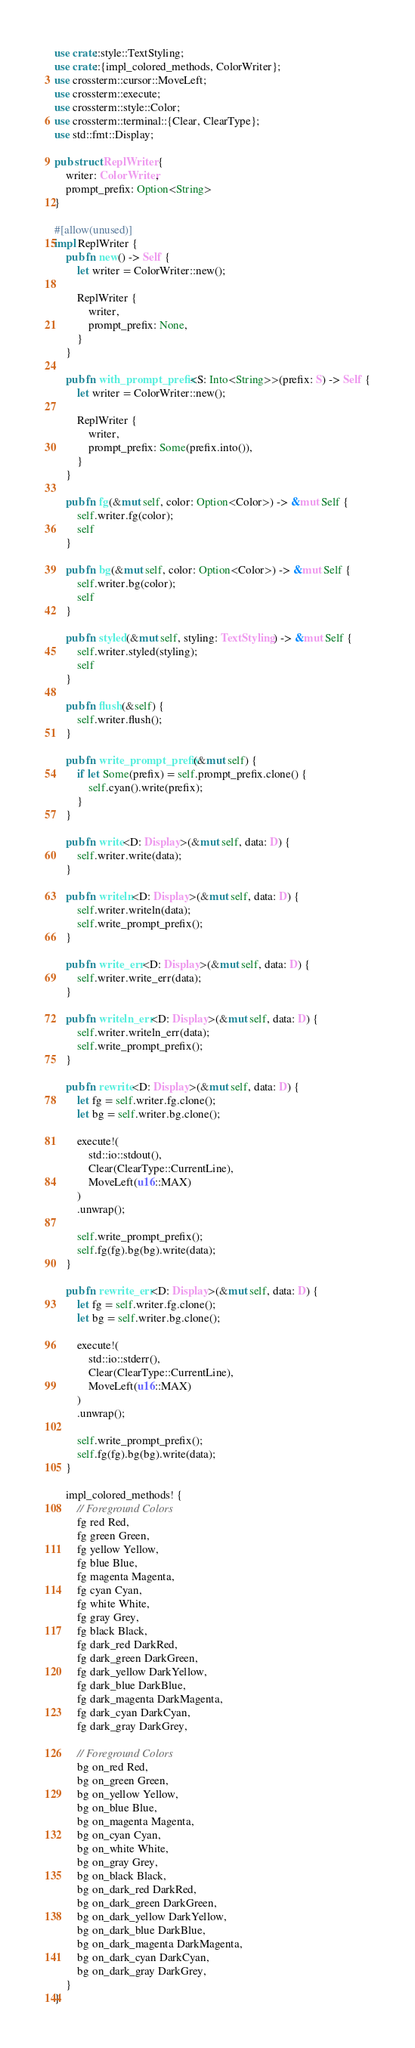Convert code to text. <code><loc_0><loc_0><loc_500><loc_500><_Rust_>use crate::style::TextStyling;
use crate::{impl_colored_methods, ColorWriter};
use crossterm::cursor::MoveLeft;
use crossterm::execute;
use crossterm::style::Color;
use crossterm::terminal::{Clear, ClearType};
use std::fmt::Display;

pub struct ReplWriter {
    writer: ColorWriter,
    prompt_prefix: Option<String>
}

#[allow(unused)]
impl ReplWriter {
    pub fn new() -> Self {
        let writer = ColorWriter::new();

        ReplWriter {
            writer,
            prompt_prefix: None,
        }
    }

    pub fn with_prompt_prefix<S: Into<String>>(prefix: S) -> Self {
        let writer = ColorWriter::new();

        ReplWriter {
            writer,
            prompt_prefix: Some(prefix.into()),
        }
    }

    pub fn fg(&mut self, color: Option<Color>) -> &mut Self {
        self.writer.fg(color);
        self
    }

    pub fn bg(&mut self, color: Option<Color>) -> &mut Self {
        self.writer.bg(color);
        self
    }

    pub fn styled(&mut self, styling: TextStyling) -> &mut Self {
        self.writer.styled(styling);
        self
    }

    pub fn flush(&self) {
        self.writer.flush();
    }

    pub fn write_prompt_prefix(&mut self) {
        if let Some(prefix) = self.prompt_prefix.clone() {
            self.cyan().write(prefix);
        }
    }

    pub fn write<D: Display>(&mut self, data: D) {
        self.writer.write(data);
    }

    pub fn writeln<D: Display>(&mut self, data: D) {
        self.writer.writeln(data);
        self.write_prompt_prefix();
    }

    pub fn write_err<D: Display>(&mut self, data: D) {
        self.writer.write_err(data);
    }

    pub fn writeln_err<D: Display>(&mut self, data: D) {
        self.writer.writeln_err(data);
        self.write_prompt_prefix();
    }

    pub fn rewrite<D: Display>(&mut self, data: D) {
        let fg = self.writer.fg.clone();
        let bg = self.writer.bg.clone();

        execute!(
            std::io::stdout(),
            Clear(ClearType::CurrentLine),
            MoveLeft(u16::MAX)
        )
        .unwrap();

        self.write_prompt_prefix();
        self.fg(fg).bg(bg).write(data);
    }

    pub fn rewrite_err<D: Display>(&mut self, data: D) {
        let fg = self.writer.fg.clone();
        let bg = self.writer.bg.clone();

        execute!(
            std::io::stderr(),
            Clear(ClearType::CurrentLine),
            MoveLeft(u16::MAX)
        )
        .unwrap();

        self.write_prompt_prefix();
        self.fg(fg).bg(bg).write(data);
    }

    impl_colored_methods! {
        // Foreground Colors
        fg red Red,
        fg green Green,
        fg yellow Yellow,
        fg blue Blue,
        fg magenta Magenta,
        fg cyan Cyan,
        fg white White,
        fg gray Grey,
        fg black Black,
        fg dark_red DarkRed,
        fg dark_green DarkGreen,
        fg dark_yellow DarkYellow,
        fg dark_blue DarkBlue,
        fg dark_magenta DarkMagenta,
        fg dark_cyan DarkCyan,
        fg dark_gray DarkGrey,

        // Foreground Colors
        bg on_red Red,
        bg on_green Green,
        bg on_yellow Yellow,
        bg on_blue Blue,
        bg on_magenta Magenta,
        bg on_cyan Cyan,
        bg on_white White,
        bg on_gray Grey,
        bg on_black Black,
        bg on_dark_red DarkRed,
        bg on_dark_green DarkGreen,
        bg on_dark_yellow DarkYellow,
        bg on_dark_blue DarkBlue,
        bg on_dark_magenta DarkMagenta,
        bg on_dark_cyan DarkCyan,
        bg on_dark_gray DarkGrey,
    }
}
</code> 